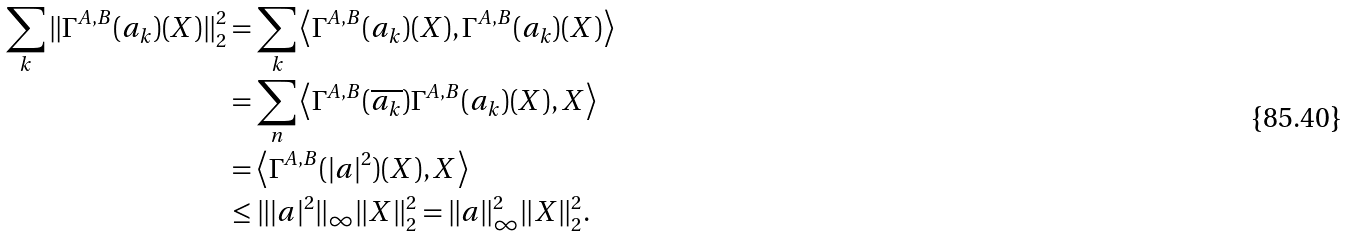Convert formula to latex. <formula><loc_0><loc_0><loc_500><loc_500>\sum _ { k } \| \Gamma ^ { A , B } ( a _ { k } ) ( X ) \| _ { 2 } ^ { 2 } & = \sum _ { k } \left \langle \Gamma ^ { A , B } ( a _ { k } ) ( X ) , \Gamma ^ { A , B } ( a _ { k } ) ( X ) \right \rangle \\ & = \sum _ { n } \left \langle \Gamma ^ { A , B } ( \overline { a _ { k } } ) \Gamma ^ { A , B } ( a _ { k } ) ( X ) , X \right \rangle \\ & = \left \langle \Gamma ^ { A , B } ( | a | ^ { 2 } ) ( X ) , X \right \rangle \\ & \leq \| | a | ^ { 2 } \| _ { \infty } \| X \| _ { 2 } ^ { 2 } = \| a \| _ { \infty } ^ { 2 } \| X \| _ { 2 } ^ { 2 } .</formula> 